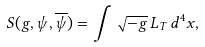Convert formula to latex. <formula><loc_0><loc_0><loc_500><loc_500>S ( g , \psi , \overline { \psi } ) = \int \sqrt { - g } \, L _ { T } \, d ^ { 4 } x ,</formula> 